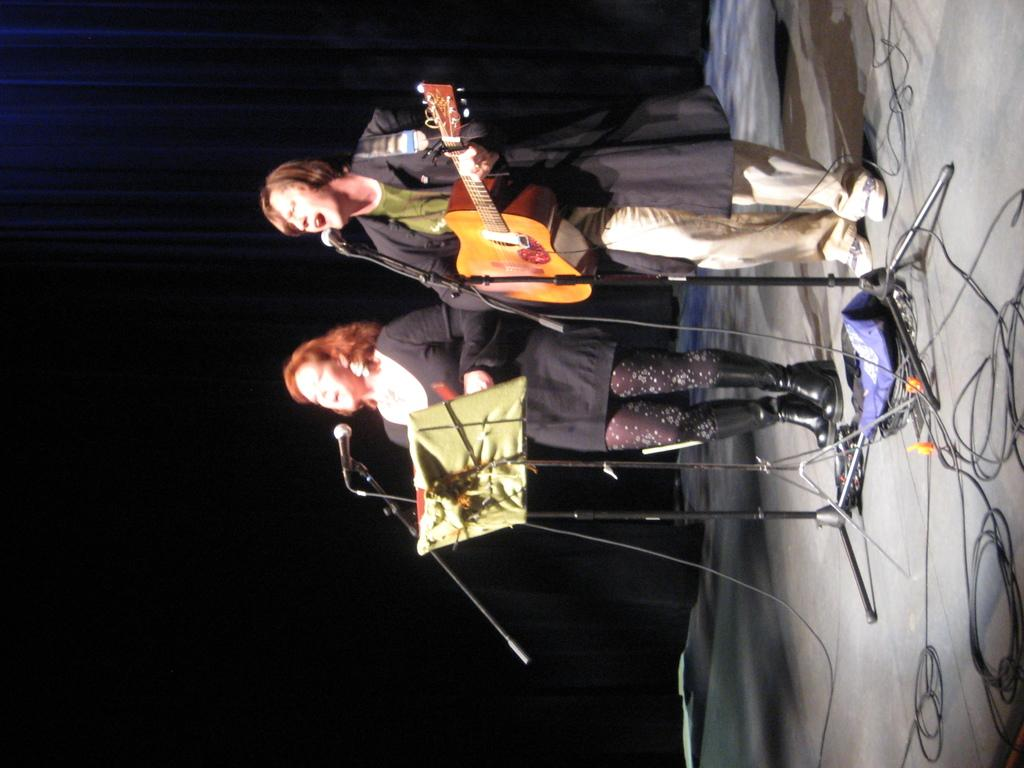What is the woman in the image doing? The woman is singing with a mic. What is in front of the singing woman? There is a stand in front of the singing woman. Who else is present in the image? Another woman is standing beside the singer, playing a guitar. What can be seen behind the two women? There is a black screen behind the two women. What type of bun is the woman wearing in the image? There is no bun visible on the woman's head in the image. How many seats are available for the audience in the image? The image does not show any seats for an audience, as it appears to be a close-up shot of the two women performing. 